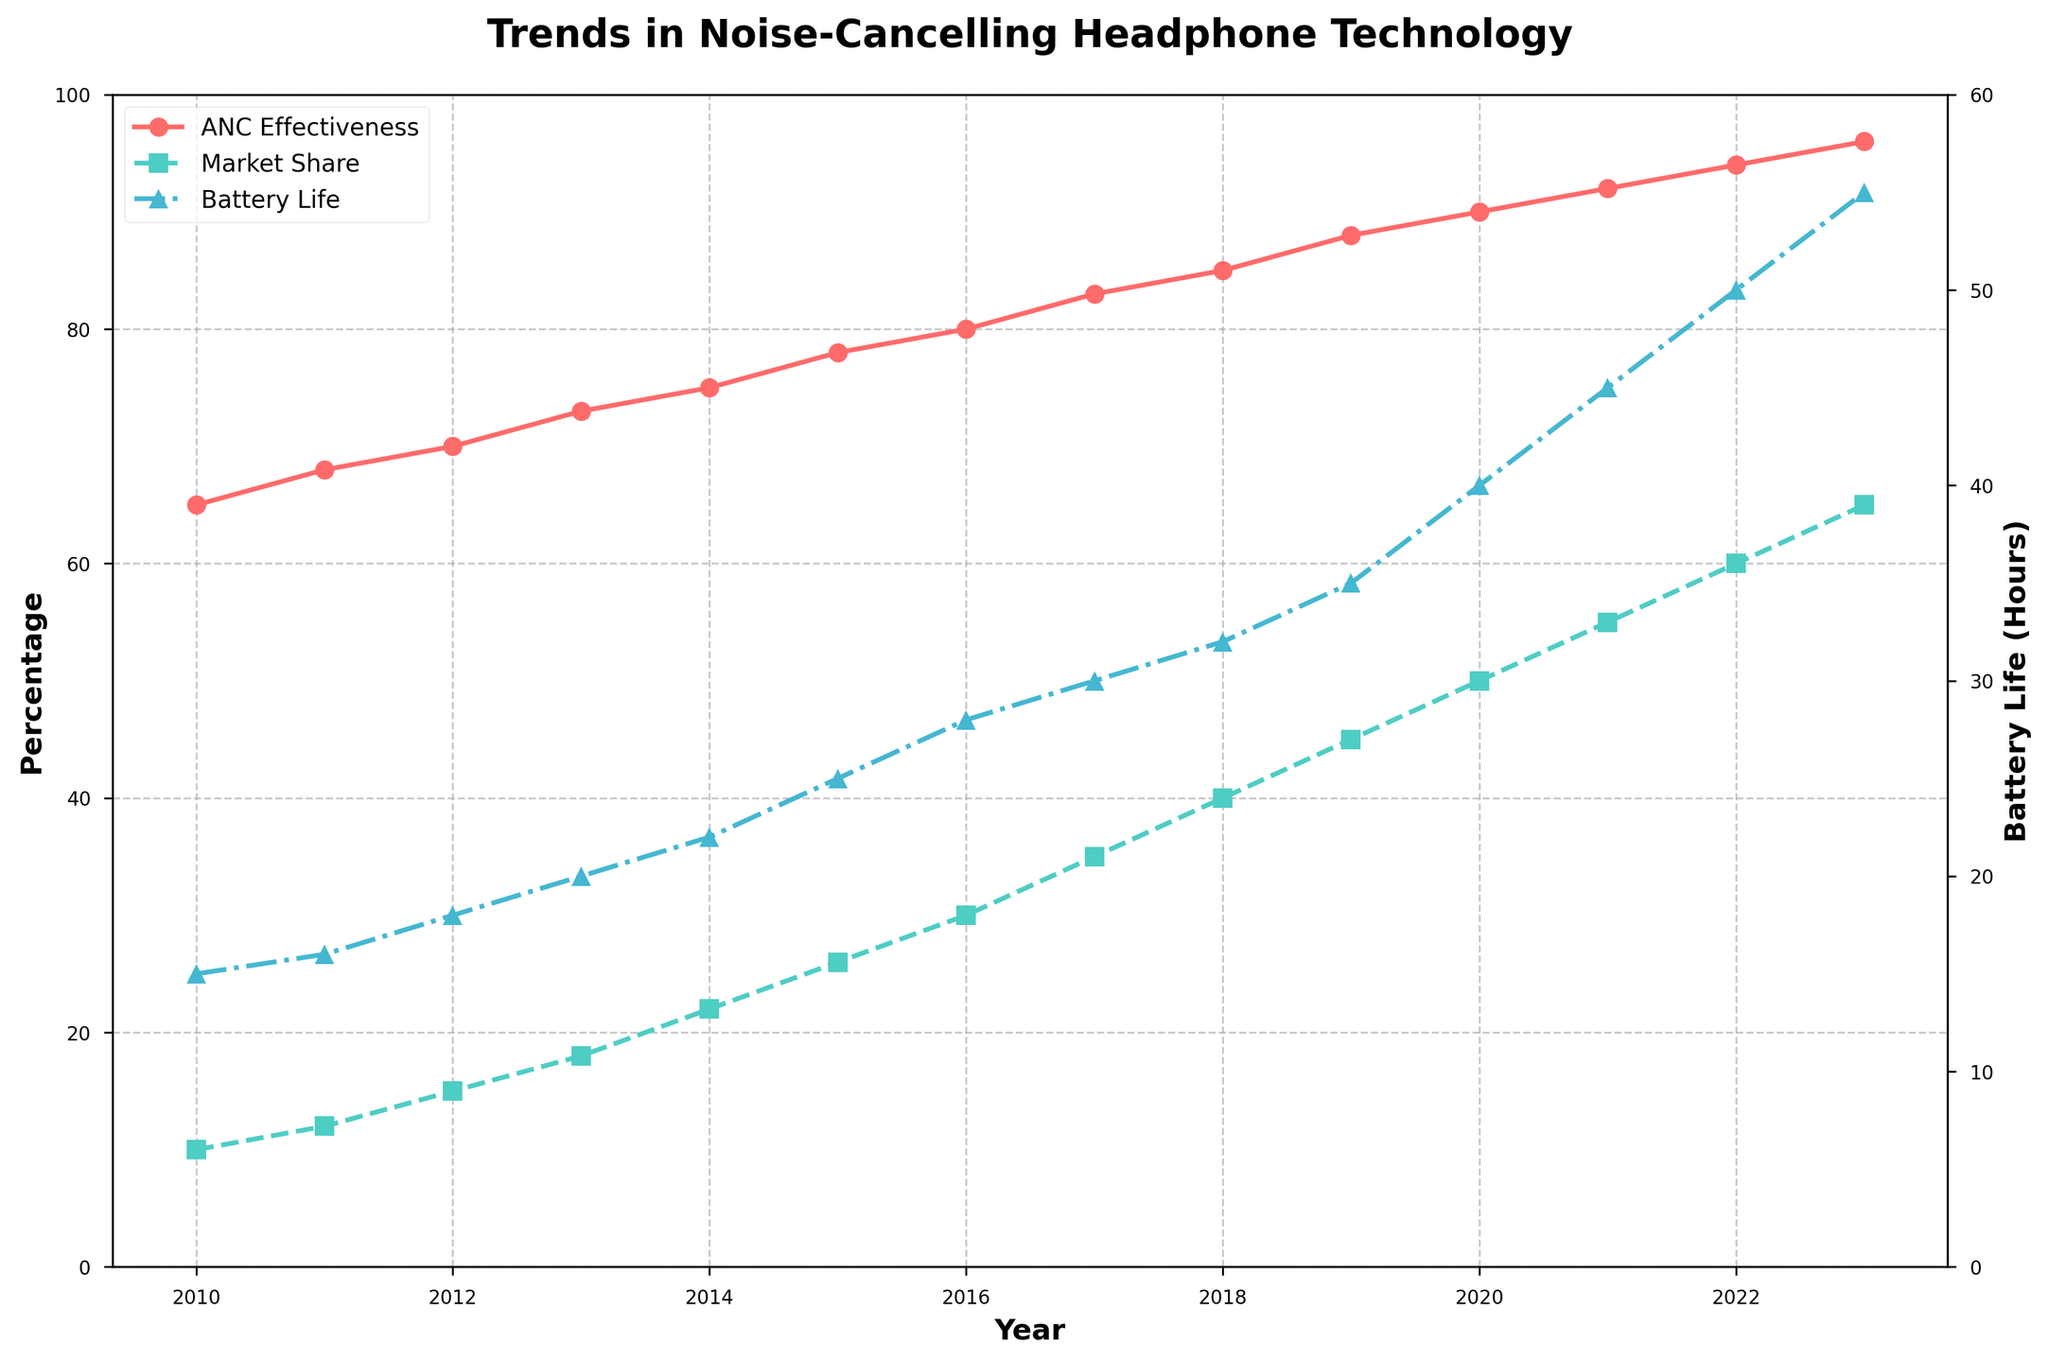What trend do you observe for the ANC effectiveness over the years? From 2010 to 2023, the ANC effectiveness shows a consistent increase. It starts at 65% in 2010 and rises gradually, reaching 96% in 2023.
Answer: Increasing How does the market share compare between the years 2015 and 2020? In 2015, the market share is at 26%, whereas, in 2020, it increases significantly to 50%. This shows a noticeable growth in market share over these five years.
Answer: 50% in 2020 > 26% in 2015 What is the difference in battery life between 2010 and 2023? In 2010, the battery life is 15 hours, and in 2023 it is 55 hours. The difference is calculated by subtracting the 2010 value from the 2023 value: 55 - 15 = 40 hours.
Answer: 40 hours How much did the ANC effectiveness increase from 2010 to 2023? The ANC effectiveness in 2010 is 65%, and in 2023 it is 96%. The increase is found by subtracting the 2010 value from the 2023 value: 96 - 65 = 31%.
Answer: 31% Which year shows the largest increase in market share compared to the previous year? From the data, the year 2011 shows an increase from 10% to 12%, which is 2%. Each subsequent year until 2021 shows incremental increases, but the largest increase occurs from 2020 to 2021, jumping from 50% to 55%, a 5% increase.
Answer: 2021 What is the average battery life over the entire period? Adding the battery life for all the years and then dividing by the number of years (14) gives the average. Sum: 15+16+18+20+22+25+28+30+32+35+40+45+50+55 = 431. Average: 431 / 14 ≈ 30.79 hours.
Answer: 30.79 hours Compare the ANC effectiveness and battery life in 2018. Which one saw a higher value when normalized to a common scale (0 to 100)? In 2018, ANC effectiveness is 85%, and battery life is 32 hours. When both are scaled (assuming battery life max is 55 hours in 2023), battery life normalized is (32/55) * 100 ≈ 58.18%. Thus, ANC effectiveness at 85% is higher than the normalized battery life.
Answer: ANC effectiveness How does the market share correlates with battery life? Observing the trend, as battery life improves year by year, the market share typically increases as well, indicating a positive correlation where better battery life coincides with higher market share.
Answer: Positive correlation 